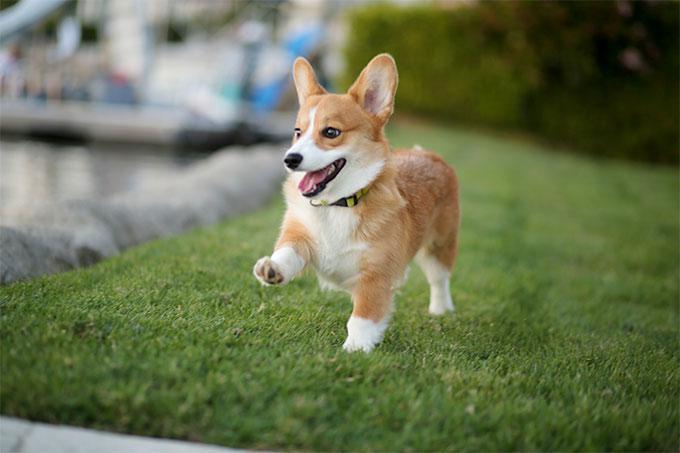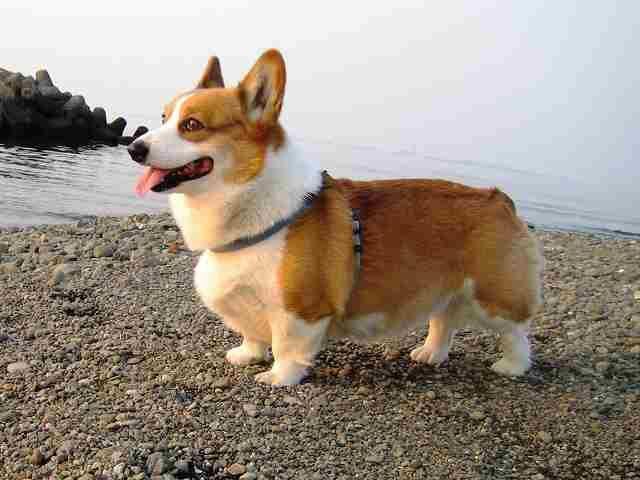The first image is the image on the left, the second image is the image on the right. Analyze the images presented: Is the assertion "The image on the right has one dog with a collar exposed." valid? Answer yes or no. Yes. The first image is the image on the left, the second image is the image on the right. Examine the images to the left and right. Is the description "In one of the image there is a dog standing in the grass." accurate? Answer yes or no. Yes. 